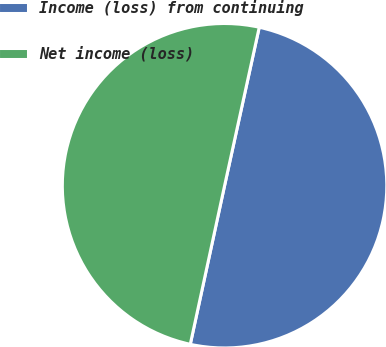<chart> <loc_0><loc_0><loc_500><loc_500><pie_chart><fcel>Income (loss) from continuing<fcel>Net income (loss)<nl><fcel>49.96%<fcel>50.04%<nl></chart> 